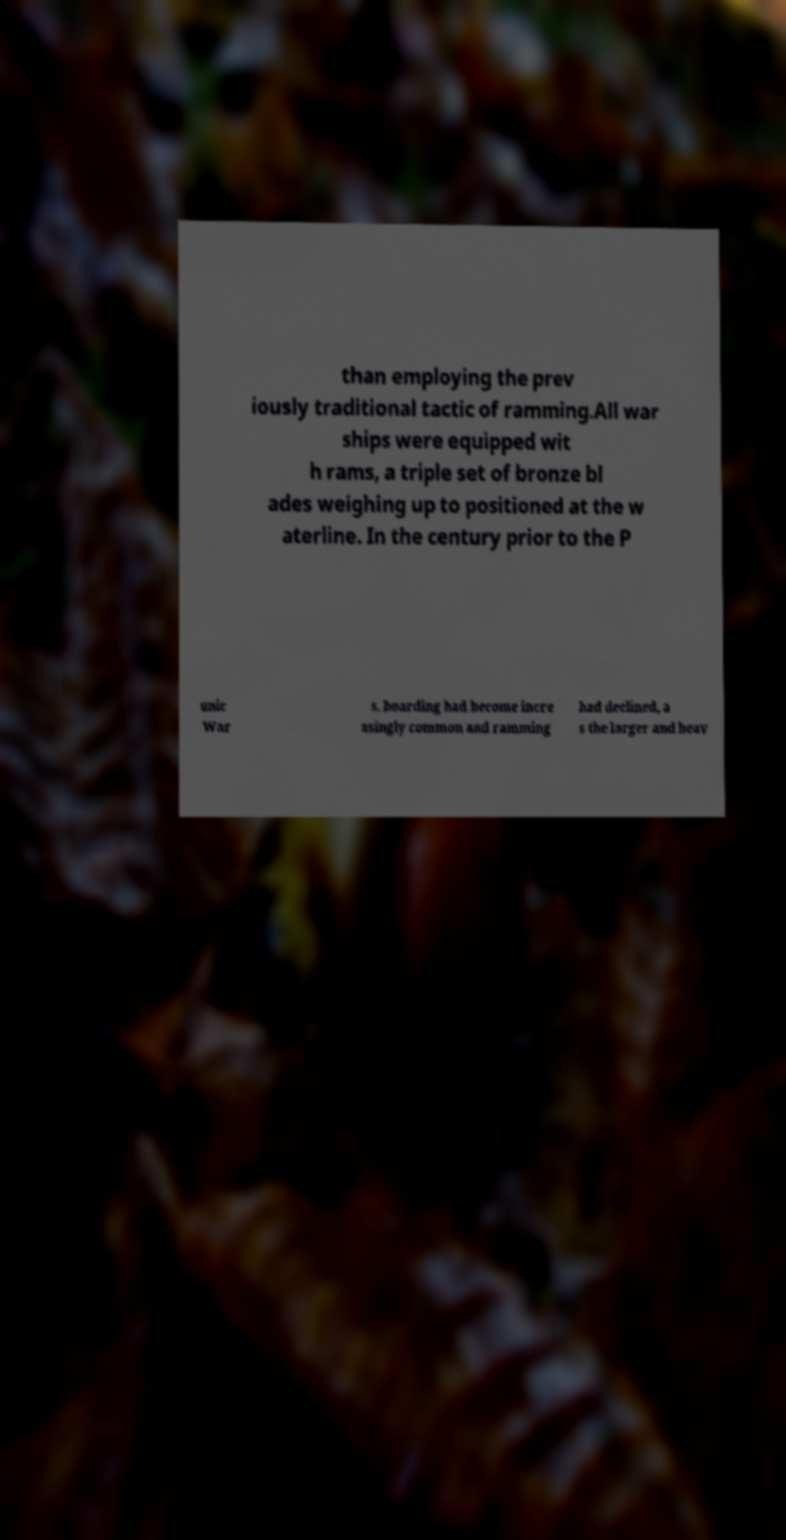Could you assist in decoding the text presented in this image and type it out clearly? than employing the prev iously traditional tactic of ramming.All war ships were equipped wit h rams, a triple set of bronze bl ades weighing up to positioned at the w aterline. In the century prior to the P unic War s, boarding had become incre asingly common and ramming had declined, a s the larger and heav 